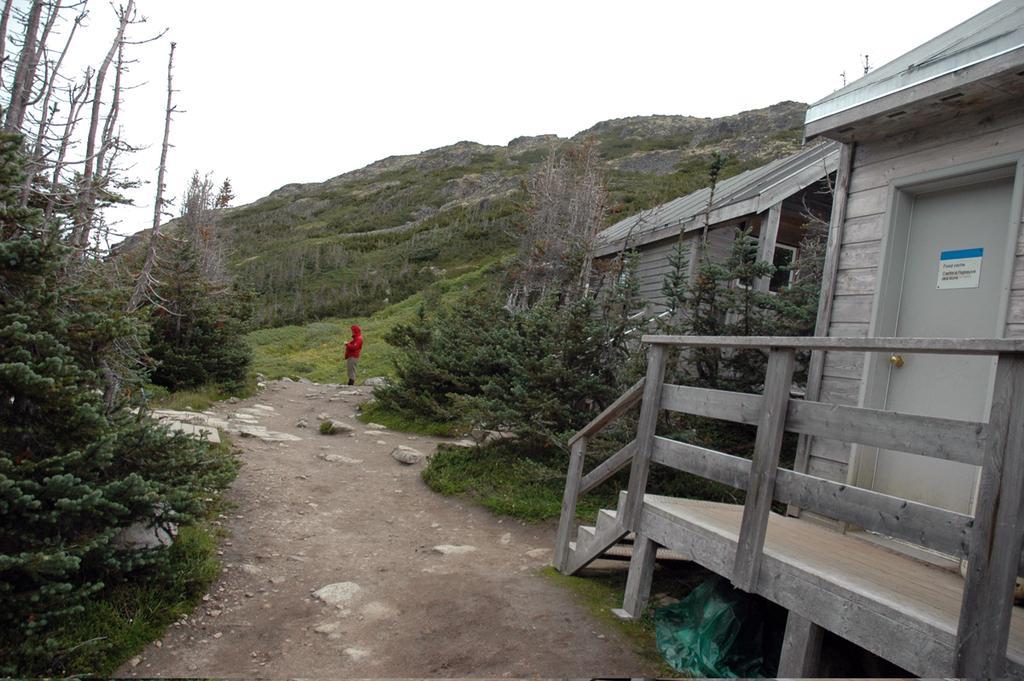In one or two sentences, can you explain what this image depicts? In this image I can see wooden houses, trees and a person is standing on the road. In the background I can see mountains and the sky. This image is taken may be near the mountains. 